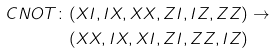Convert formula to latex. <formula><loc_0><loc_0><loc_500><loc_500>C N O T \colon & ( X I , I X , X X , Z I , I Z , Z Z ) \rightarrow \\ & ( X X , I X , X I , Z I , Z Z , I Z )</formula> 